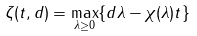Convert formula to latex. <formula><loc_0><loc_0><loc_500><loc_500>\zeta ( t , d ) = \max _ { \lambda \geq 0 } \{ d \lambda - \chi ( \lambda ) t \}</formula> 